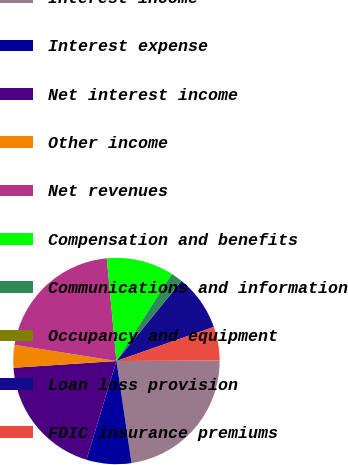Convert chart. <chart><loc_0><loc_0><loc_500><loc_500><pie_chart><fcel>Interest income<fcel>Interest expense<fcel>Net interest income<fcel>Other income<fcel>Net revenues<fcel>Compensation and benefits<fcel>Communications and information<fcel>Occupancy and equipment<fcel>Loan loss provision<fcel>FDIC insurance premiums<nl><fcel>22.75%<fcel>7.03%<fcel>19.26%<fcel>3.54%<fcel>21.01%<fcel>10.52%<fcel>1.79%<fcel>0.04%<fcel>8.78%<fcel>5.28%<nl></chart> 